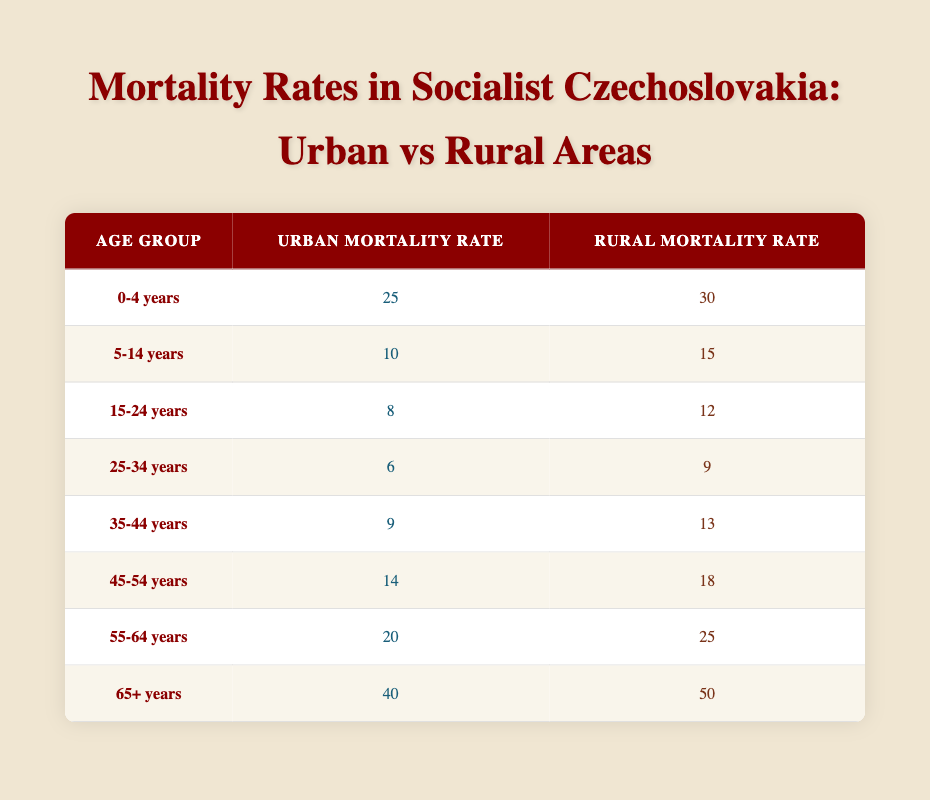What is the urban mortality rate for the age group 0-4 years? According to the table, the urban mortality rate for the age group 0-4 years is directly listed as 25.
Answer: 25 What is the rural mortality rate for the age group 65+ years? The table shows that the rural mortality rate for the age group 65+ years is 50.
Answer: 50 Which age group has the highest urban mortality rate? By comparing all age groups listed in the table, the age group 65+ years has the highest urban mortality rate at 40.
Answer: 65+ years Is the urban mortality rate for age group 25-34 years lower than that of age group 35-44 years? The urban mortality rate for 25-34 years is 6 and for 35-44 years is 9. Since 6 is less than 9, the statement is true.
Answer: Yes What is the difference between the rural mortality rates for the age groups 5-14 years and 15-24 years? The rural mortality rate for 5-14 years is 15, and for 15-24 years, it is 12. The difference is calculated as 15 - 12 = 3.
Answer: 3 What is the average rural mortality rate for all age groups? To find the average, sum all the rural mortality rates: 30 + 15 + 12 + 9 + 13 + 18 + 25 + 50 = 172. There are 8 age groups, so the average is 172 / 8 = 21.5.
Answer: 21.5 Are rural mortality rates higher than urban mortality rates for every age group? By examining each age group in the table, rural rates are higher in all cases: 30 vs 25, 15 vs 10, 12 vs 8, 9 vs 6, 13 vs 9, 18 vs 14, 25 vs 20, and 50 vs 40. Hence, the statement is true.
Answer: Yes Which age group has the smallest rural mortality rate? By checking the table, the age group 25-34 years has the smallest rural mortality rate at 9, compared to other age groups.
Answer: 25-34 years What is the combined urban mortality rate for the age groups 45-54 years and 55-64 years? The urban mortality rate for 45-54 years is 14 and for 55-64 years is 20. Combining these gives 14 + 20 = 34.
Answer: 34 